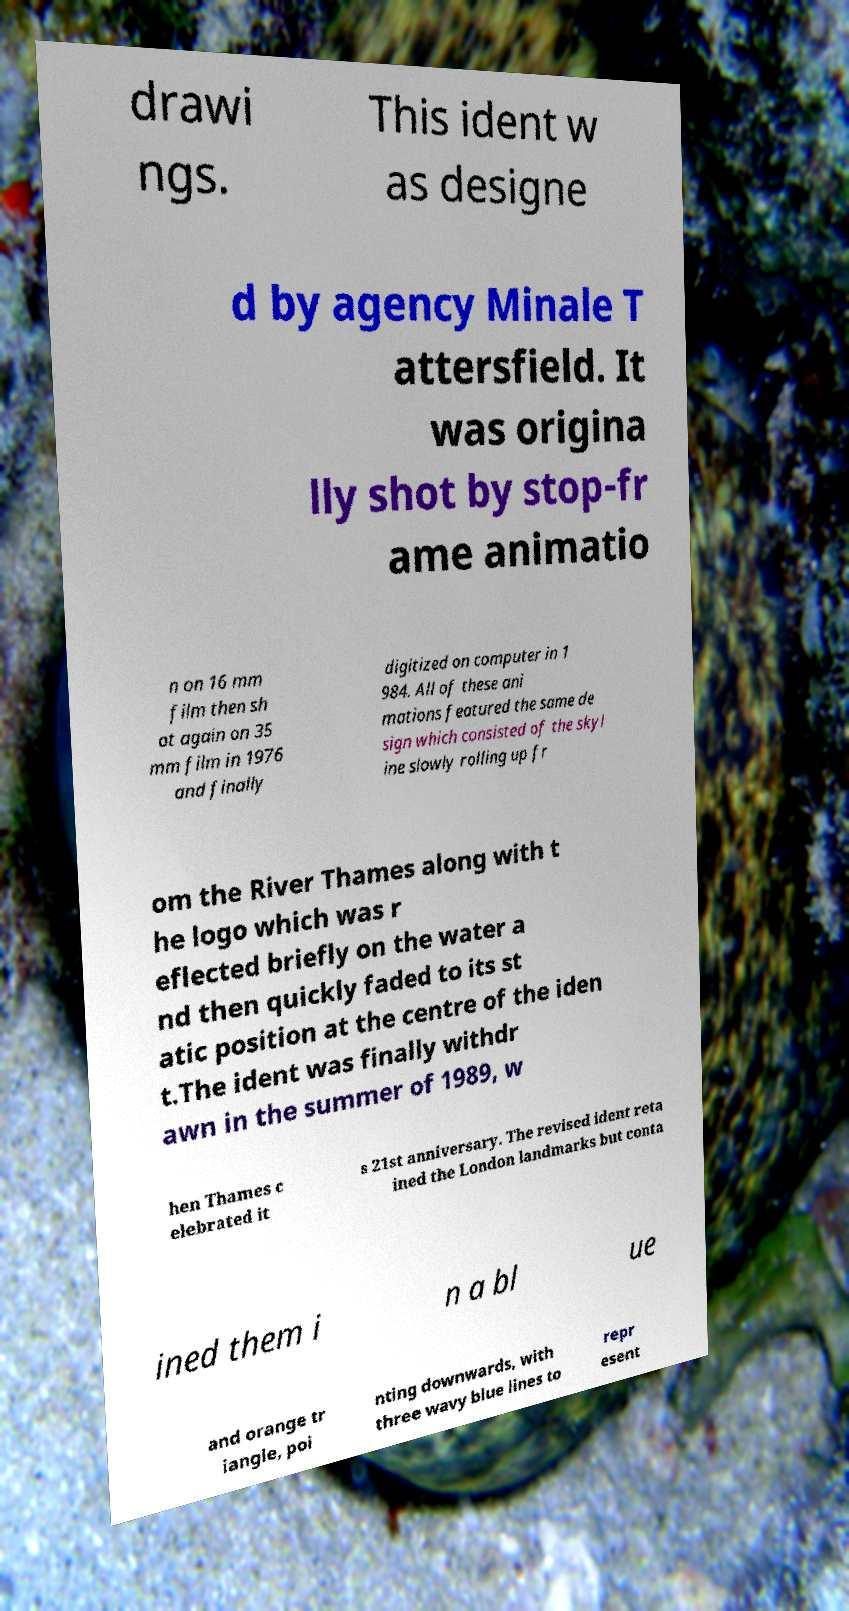Please identify and transcribe the text found in this image. drawi ngs. This ident w as designe d by agency Minale T attersfield. It was origina lly shot by stop-fr ame animatio n on 16 mm film then sh ot again on 35 mm film in 1976 and finally digitized on computer in 1 984. All of these ani mations featured the same de sign which consisted of the skyl ine slowly rolling up fr om the River Thames along with t he logo which was r eflected briefly on the water a nd then quickly faded to its st atic position at the centre of the iden t.The ident was finally withdr awn in the summer of 1989, w hen Thames c elebrated it s 21st anniversary. The revised ident reta ined the London landmarks but conta ined them i n a bl ue and orange tr iangle, poi nting downwards, with three wavy blue lines to repr esent 